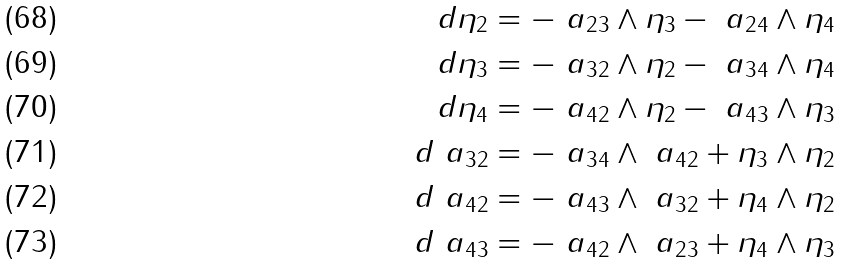Convert formula to latex. <formula><loc_0><loc_0><loc_500><loc_500>d \eta _ { 2 } & = - \ a _ { 2 3 } \wedge \eta _ { 3 } - \ a _ { 2 4 } \wedge \eta _ { 4 } \\ d \eta _ { 3 } & = - \ a _ { 3 2 } \wedge \eta _ { 2 } - \ a _ { 3 4 } \wedge \eta _ { 4 } \\ d \eta _ { 4 } & = - \ a _ { 4 2 } \wedge \eta _ { 2 } - \ a _ { 4 3 } \wedge \eta _ { 3 } \\ d \ a _ { 3 2 } & = - \ a _ { 3 4 } \wedge \ a _ { 4 2 } + \eta _ { 3 } \wedge \eta _ { 2 } \\ d \ a _ { 4 2 } & = - \ a _ { 4 3 } \wedge \ a _ { 3 2 } + \eta _ { 4 } \wedge \eta _ { 2 } \\ d \ a _ { 4 3 } & = - \ a _ { 4 2 } \wedge \ a _ { 2 3 } + \eta _ { 4 } \wedge \eta _ { 3 }</formula> 